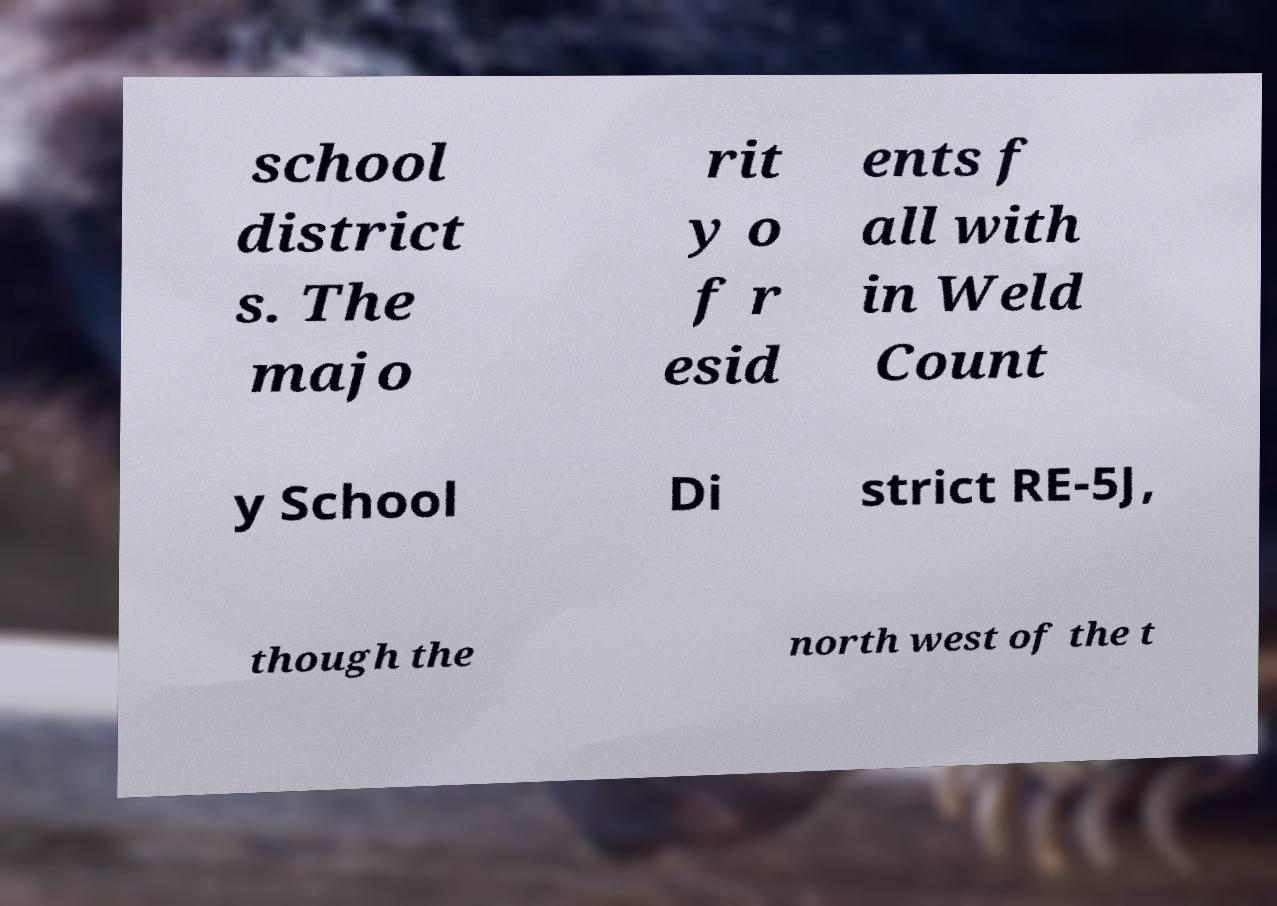For documentation purposes, I need the text within this image transcribed. Could you provide that? school district s. The majo rit y o f r esid ents f all with in Weld Count y School Di strict RE-5J, though the north west of the t 